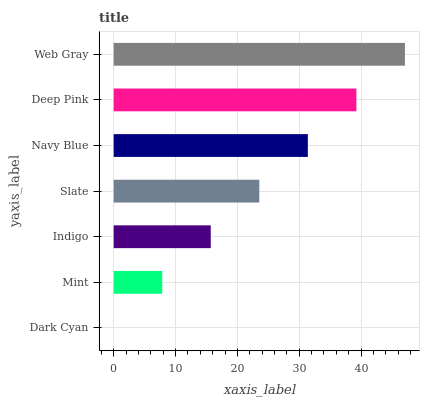Is Dark Cyan the minimum?
Answer yes or no. Yes. Is Web Gray the maximum?
Answer yes or no. Yes. Is Mint the minimum?
Answer yes or no. No. Is Mint the maximum?
Answer yes or no. No. Is Mint greater than Dark Cyan?
Answer yes or no. Yes. Is Dark Cyan less than Mint?
Answer yes or no. Yes. Is Dark Cyan greater than Mint?
Answer yes or no. No. Is Mint less than Dark Cyan?
Answer yes or no. No. Is Slate the high median?
Answer yes or no. Yes. Is Slate the low median?
Answer yes or no. Yes. Is Deep Pink the high median?
Answer yes or no. No. Is Mint the low median?
Answer yes or no. No. 